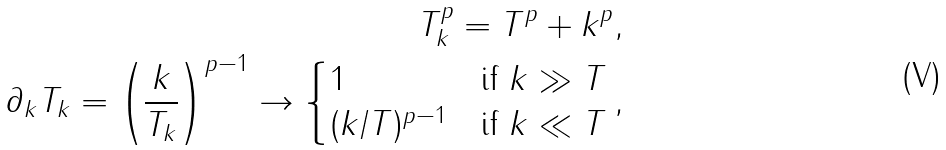<formula> <loc_0><loc_0><loc_500><loc_500>T _ { k } ^ { p } = T ^ { p } + k ^ { p } , \\ \partial _ { k } T _ { k } = \left ( \frac { k } { T _ { k } } \right ) ^ { p - 1 } \to \begin{cases} 1 & \text {if } k \gg T \\ ( k / T ) ^ { p - 1 } & \text {if } k \ll T \end{cases} ,</formula> 